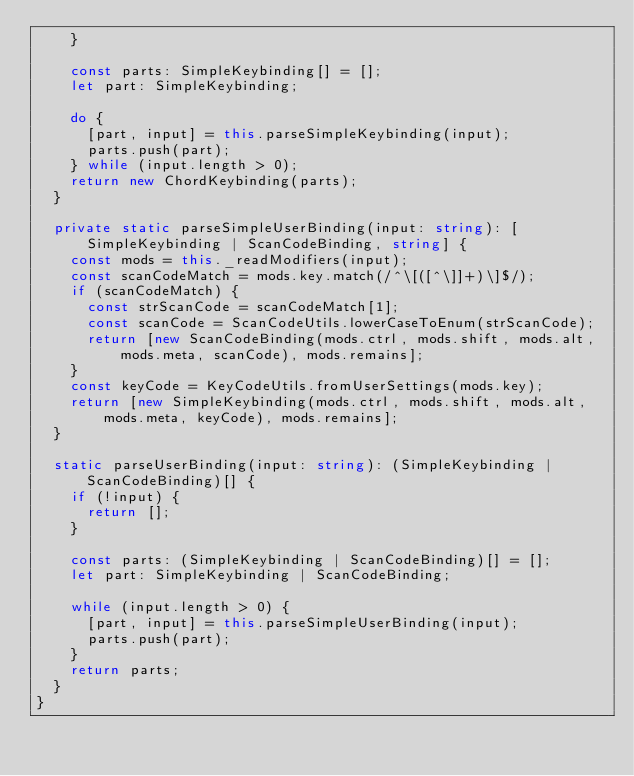<code> <loc_0><loc_0><loc_500><loc_500><_TypeScript_>		}

		const parts: SimpleKeybinding[] = [];
		let part: SimpleKeybinding;

		do {
			[part, input] = this.parseSimpleKeybinding(input);
			parts.push(part);
		} while (input.length > 0);
		return new ChordKeybinding(parts);
	}

	private static parseSimpleUserBinding(input: string): [SimpleKeybinding | ScanCodeBinding, string] {
		const mods = this._readModifiers(input);
		const scanCodeMatch = mods.key.match(/^\[([^\]]+)\]$/);
		if (scanCodeMatch) {
			const strScanCode = scanCodeMatch[1];
			const scanCode = ScanCodeUtils.lowerCaseToEnum(strScanCode);
			return [new ScanCodeBinding(mods.ctrl, mods.shift, mods.alt, mods.meta, scanCode), mods.remains];
		}
		const keyCode = KeyCodeUtils.fromUserSettings(mods.key);
		return [new SimpleKeybinding(mods.ctrl, mods.shift, mods.alt, mods.meta, keyCode), mods.remains];
	}

	static parseUserBinding(input: string): (SimpleKeybinding | ScanCodeBinding)[] {
		if (!input) {
			return [];
		}

		const parts: (SimpleKeybinding | ScanCodeBinding)[] = [];
		let part: SimpleKeybinding | ScanCodeBinding;

		while (input.length > 0) {
			[part, input] = this.parseSimpleUserBinding(input);
			parts.push(part);
		}
		return parts;
	}
}</code> 